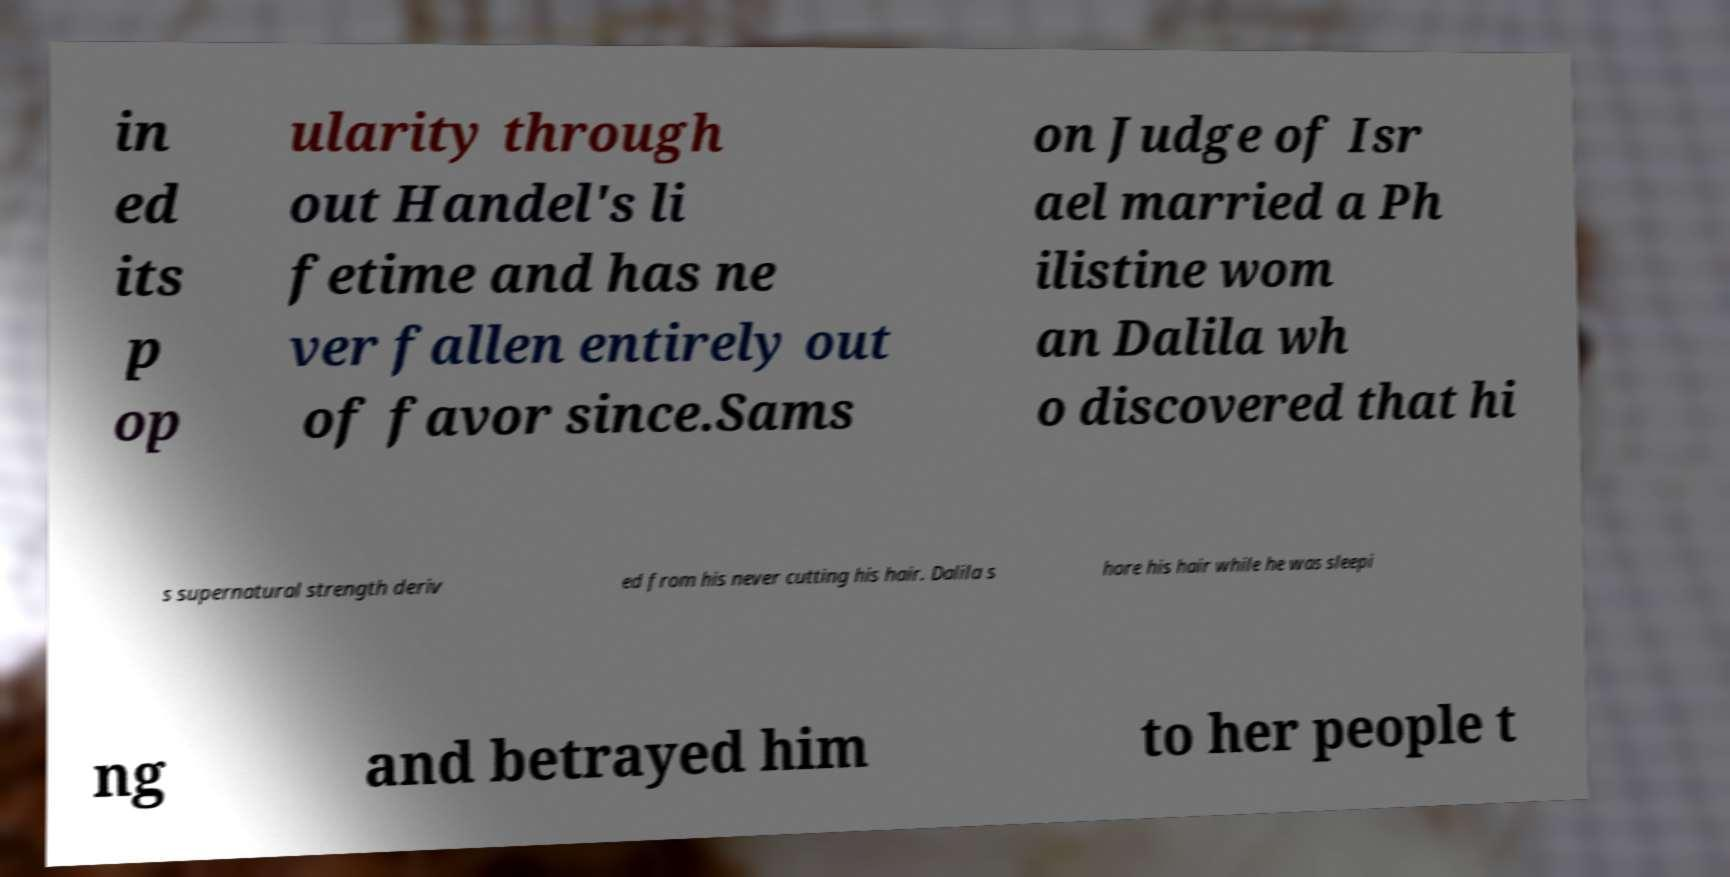What messages or text are displayed in this image? I need them in a readable, typed format. in ed its p op ularity through out Handel's li fetime and has ne ver fallen entirely out of favor since.Sams on Judge of Isr ael married a Ph ilistine wom an Dalila wh o discovered that hi s supernatural strength deriv ed from his never cutting his hair. Dalila s hore his hair while he was sleepi ng and betrayed him to her people t 